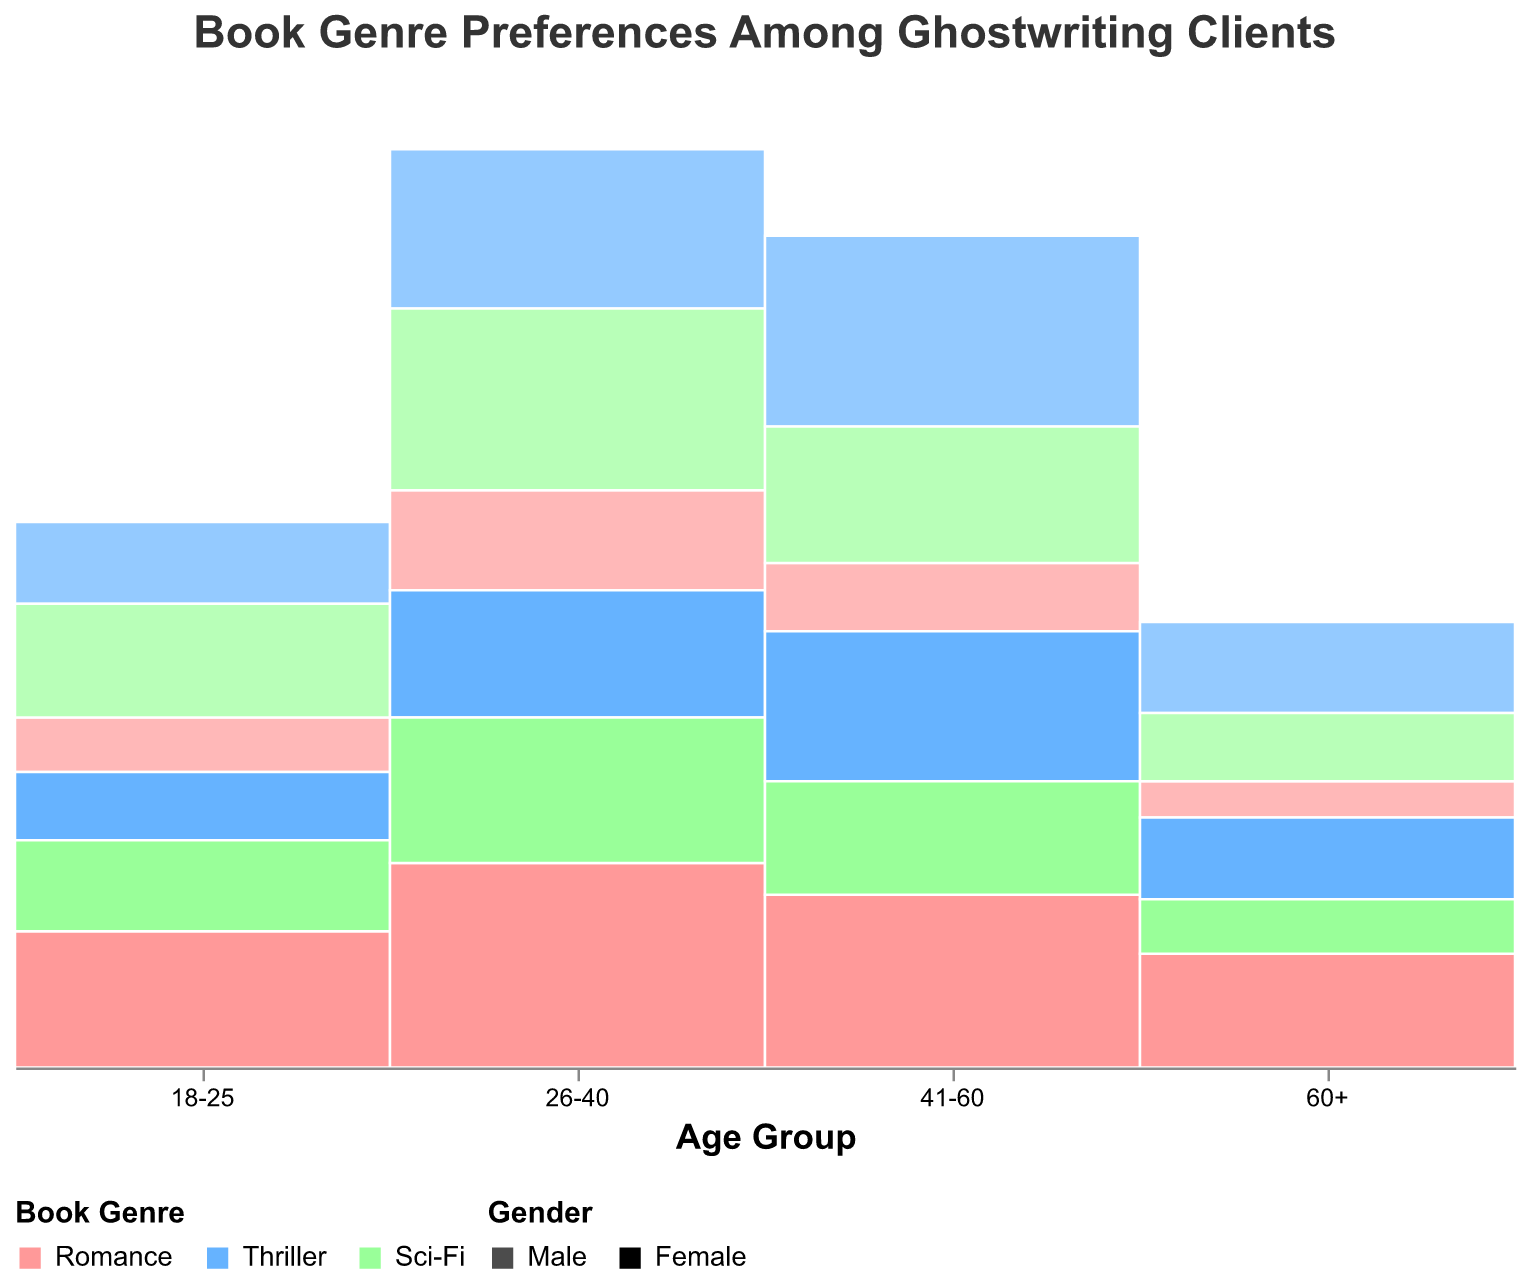What is the title of the figure? The title of the figure is usually displayed at the top. It provides a brief summary of what the figure represents.
Answer: Book Genre Preferences Among Ghostwriting Clients Which age group shows the highest preference for Romance genre among females? To determine this, look at the section of the mosaic plot corresponding to the Romance genre for each age group and compare the heights of the segments for females.
Answer: 26-40 Among males, which genre is most popular in the 41-60 age group? Compare the heights of the segments for the 41-60 age group under the male category within the mosaic plot. The tallest segment corresponds to the most popular genre.
Answer: Thriller What percentage of 26-40-year-old females prefer Sci-Fi? Hover over the Sci-Fi section of the 26-40 female segment to get the tooltip displaying the percentage.
Answer: ≈ 25.20% How does the preference for Thrillers differ between males and females in the 60+ age group? Compare the heights of the Thriller segments for males and females in the 60+ age group.
Answer: Females prefer it slightly less than males What is the trend in Sci-Fi preference among males across all age groups? Observe the Sci-Fi segments for males in each age group and compare their relative heights to analyze the trend.
Answer: Peaks at 26-40, then decreases Which gender shows a higher overall preference for Romance in the 18-25 age group? Compare the segment heights for Romance between males and females in the 18-25 age group.
Answer: Female What are the age groups with the highest preferences for Sci-Fi in both genders combined? Combine the heights of the segments for Sci-Fi in both genders and compare across age groups.
Answer: 26-40 Among 18-25-year-olds, what is the ratio of males preferring Thrillers to females preferring Thrillers? Look at the segment sizes for Thrillers in males and females within the 18-25 age group and compute the ratio of heights.
Answer: 1.2:1 Which genre shows the least variation in preference across all age groups and genders? Observe the consistency in segment heights for each genre across all age groups and genders in the mosaic plot.
Answer: Sci-Fi 